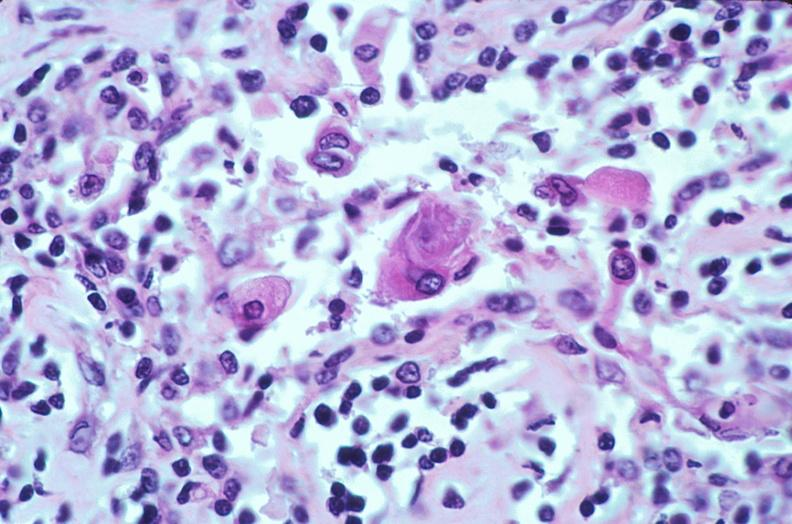what does this image show?
Answer the question using a single word or phrase. Lymph nodes 